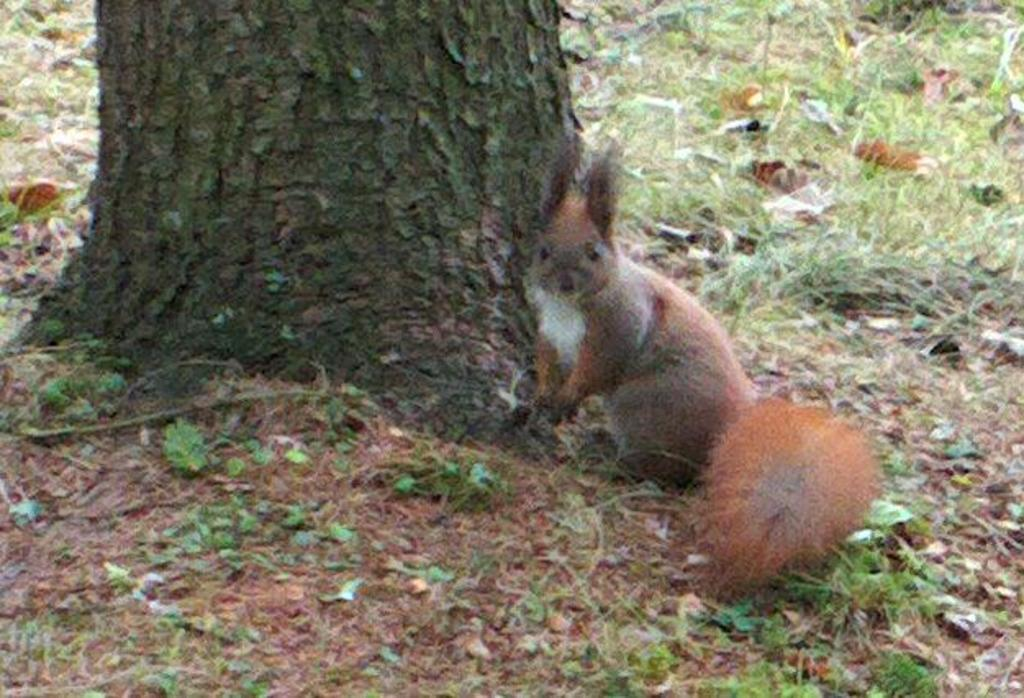What is the main object in the image? There is a tree trunk in the image. What animal is present in the image? A squirrel is sitting on the ground beside the tree trunk. What type of vegetation is visible in the image? There is a lot of grass in the image. What can be found around the squirrel? There are dry leaves around the squirrel. What caption is written on the image? There is no caption written on the image. What error can be found in the image? There is no error present in the image. 